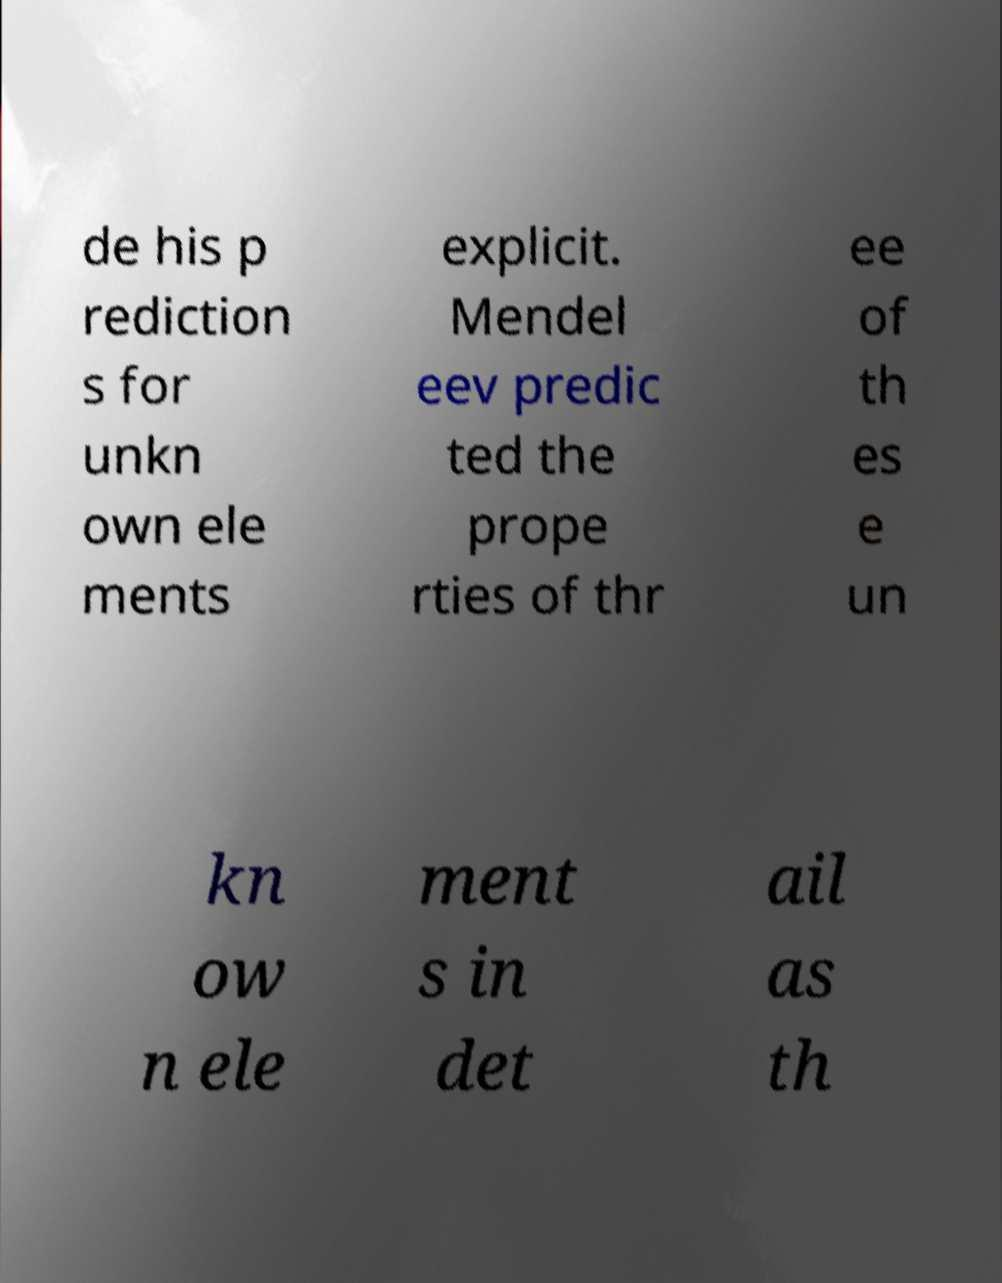There's text embedded in this image that I need extracted. Can you transcribe it verbatim? de his p rediction s for unkn own ele ments explicit. Mendel eev predic ted the prope rties of thr ee of th es e un kn ow n ele ment s in det ail as th 